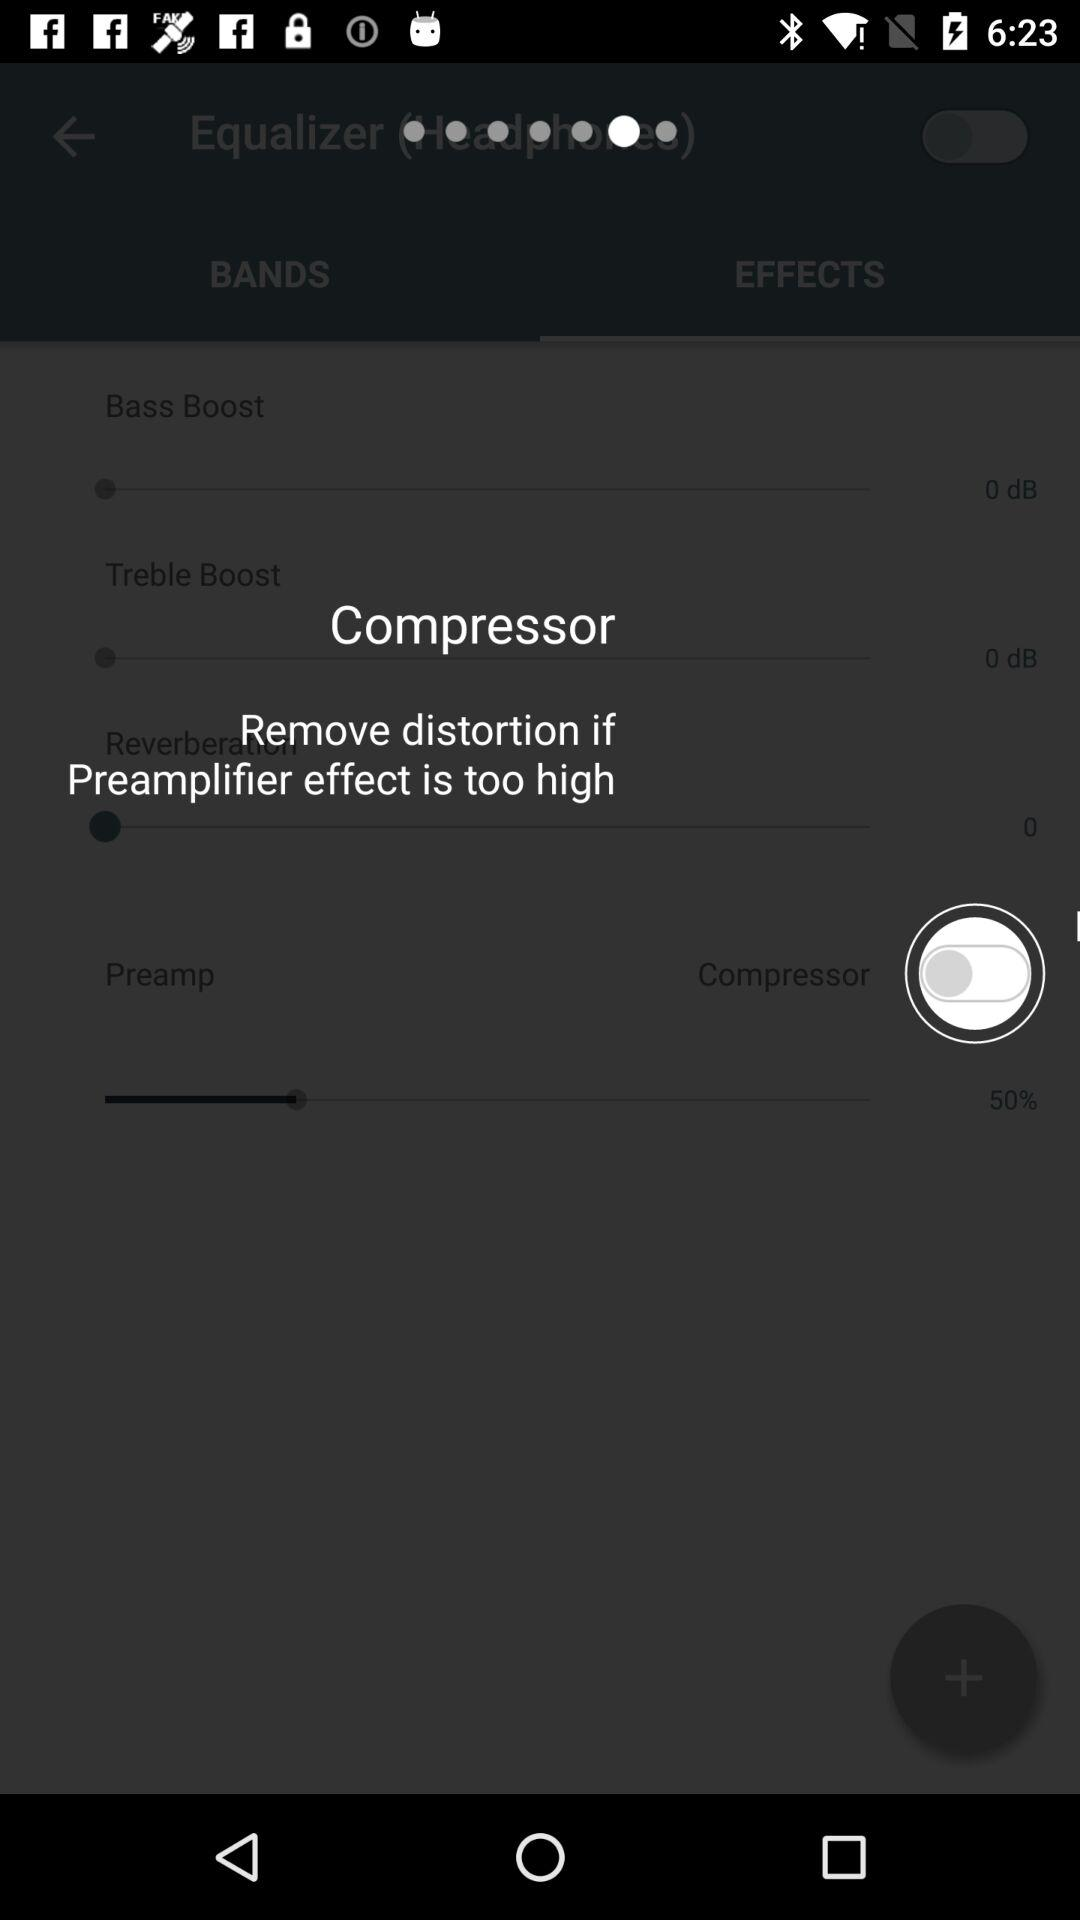What is the percentage of the Reverber effect?
Answer the question using a single word or phrase. 50% 